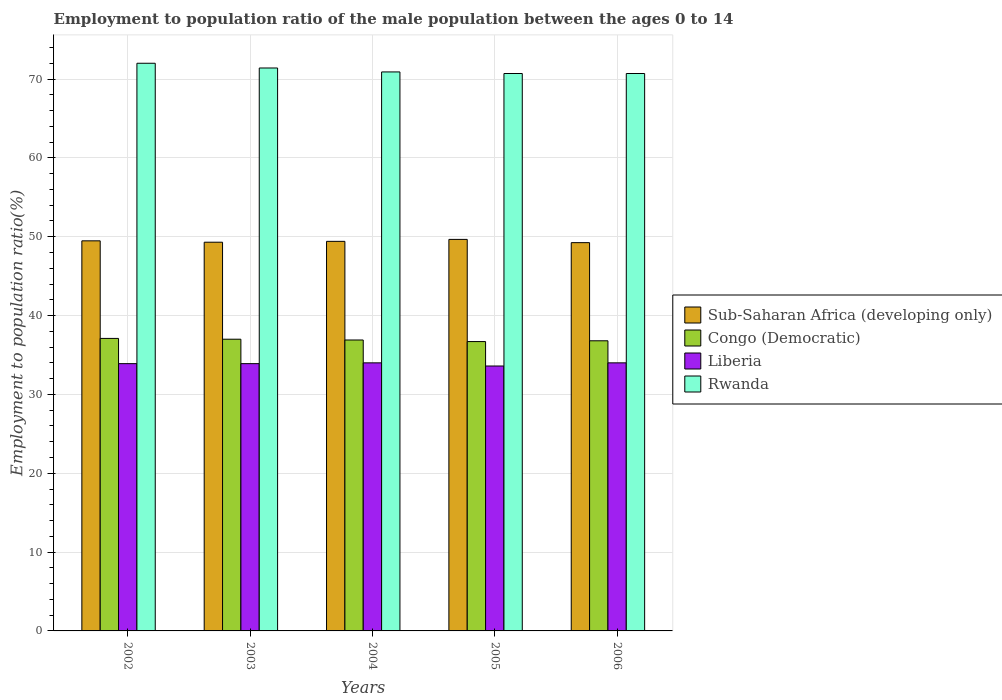How many different coloured bars are there?
Your answer should be very brief. 4. How many groups of bars are there?
Ensure brevity in your answer.  5. Are the number of bars per tick equal to the number of legend labels?
Give a very brief answer. Yes. Are the number of bars on each tick of the X-axis equal?
Keep it short and to the point. Yes. How many bars are there on the 4th tick from the left?
Provide a short and direct response. 4. What is the label of the 2nd group of bars from the left?
Provide a short and direct response. 2003. Across all years, what is the maximum employment to population ratio in Liberia?
Provide a succinct answer. 34. Across all years, what is the minimum employment to population ratio in Liberia?
Offer a terse response. 33.6. In which year was the employment to population ratio in Rwanda maximum?
Provide a succinct answer. 2002. In which year was the employment to population ratio in Rwanda minimum?
Provide a succinct answer. 2005. What is the total employment to population ratio in Rwanda in the graph?
Ensure brevity in your answer.  355.7. What is the difference between the employment to population ratio in Sub-Saharan Africa (developing only) in 2002 and that in 2004?
Provide a short and direct response. 0.07. What is the difference between the employment to population ratio in Congo (Democratic) in 2002 and the employment to population ratio in Sub-Saharan Africa (developing only) in 2004?
Offer a terse response. -12.31. What is the average employment to population ratio in Rwanda per year?
Provide a short and direct response. 71.14. In the year 2006, what is the difference between the employment to population ratio in Rwanda and employment to population ratio in Liberia?
Give a very brief answer. 36.7. What is the ratio of the employment to population ratio in Congo (Democratic) in 2002 to that in 2004?
Make the answer very short. 1.01. Is the difference between the employment to population ratio in Rwanda in 2002 and 2005 greater than the difference between the employment to population ratio in Liberia in 2002 and 2005?
Ensure brevity in your answer.  Yes. What is the difference between the highest and the second highest employment to population ratio in Rwanda?
Offer a terse response. 0.6. What is the difference between the highest and the lowest employment to population ratio in Liberia?
Give a very brief answer. 0.4. Is it the case that in every year, the sum of the employment to population ratio in Liberia and employment to population ratio in Congo (Democratic) is greater than the sum of employment to population ratio in Sub-Saharan Africa (developing only) and employment to population ratio in Rwanda?
Give a very brief answer. Yes. What does the 2nd bar from the left in 2004 represents?
Provide a succinct answer. Congo (Democratic). What does the 2nd bar from the right in 2006 represents?
Your answer should be very brief. Liberia. Is it the case that in every year, the sum of the employment to population ratio in Congo (Democratic) and employment to population ratio in Rwanda is greater than the employment to population ratio in Sub-Saharan Africa (developing only)?
Keep it short and to the point. Yes. How many bars are there?
Make the answer very short. 20. How many legend labels are there?
Provide a short and direct response. 4. How are the legend labels stacked?
Your answer should be compact. Vertical. What is the title of the graph?
Your answer should be very brief. Employment to population ratio of the male population between the ages 0 to 14. What is the label or title of the X-axis?
Ensure brevity in your answer.  Years. What is the Employment to population ratio(%) in Sub-Saharan Africa (developing only) in 2002?
Provide a short and direct response. 49.48. What is the Employment to population ratio(%) of Congo (Democratic) in 2002?
Your response must be concise. 37.1. What is the Employment to population ratio(%) of Liberia in 2002?
Your response must be concise. 33.9. What is the Employment to population ratio(%) in Sub-Saharan Africa (developing only) in 2003?
Provide a succinct answer. 49.3. What is the Employment to population ratio(%) of Liberia in 2003?
Keep it short and to the point. 33.9. What is the Employment to population ratio(%) of Rwanda in 2003?
Provide a short and direct response. 71.4. What is the Employment to population ratio(%) of Sub-Saharan Africa (developing only) in 2004?
Offer a very short reply. 49.41. What is the Employment to population ratio(%) of Congo (Democratic) in 2004?
Your answer should be compact. 36.9. What is the Employment to population ratio(%) of Liberia in 2004?
Keep it short and to the point. 34. What is the Employment to population ratio(%) in Rwanda in 2004?
Provide a succinct answer. 70.9. What is the Employment to population ratio(%) in Sub-Saharan Africa (developing only) in 2005?
Make the answer very short. 49.66. What is the Employment to population ratio(%) in Congo (Democratic) in 2005?
Your answer should be very brief. 36.7. What is the Employment to population ratio(%) of Liberia in 2005?
Offer a terse response. 33.6. What is the Employment to population ratio(%) of Rwanda in 2005?
Provide a succinct answer. 70.7. What is the Employment to population ratio(%) in Sub-Saharan Africa (developing only) in 2006?
Offer a very short reply. 49.25. What is the Employment to population ratio(%) in Congo (Democratic) in 2006?
Make the answer very short. 36.8. What is the Employment to population ratio(%) in Rwanda in 2006?
Your answer should be compact. 70.7. Across all years, what is the maximum Employment to population ratio(%) in Sub-Saharan Africa (developing only)?
Give a very brief answer. 49.66. Across all years, what is the maximum Employment to population ratio(%) of Congo (Democratic)?
Your answer should be very brief. 37.1. Across all years, what is the minimum Employment to population ratio(%) of Sub-Saharan Africa (developing only)?
Your response must be concise. 49.25. Across all years, what is the minimum Employment to population ratio(%) of Congo (Democratic)?
Ensure brevity in your answer.  36.7. Across all years, what is the minimum Employment to population ratio(%) of Liberia?
Keep it short and to the point. 33.6. Across all years, what is the minimum Employment to population ratio(%) in Rwanda?
Make the answer very short. 70.7. What is the total Employment to population ratio(%) of Sub-Saharan Africa (developing only) in the graph?
Give a very brief answer. 247.1. What is the total Employment to population ratio(%) of Congo (Democratic) in the graph?
Offer a terse response. 184.5. What is the total Employment to population ratio(%) of Liberia in the graph?
Make the answer very short. 169.4. What is the total Employment to population ratio(%) in Rwanda in the graph?
Provide a succinct answer. 355.7. What is the difference between the Employment to population ratio(%) in Sub-Saharan Africa (developing only) in 2002 and that in 2003?
Your answer should be compact. 0.18. What is the difference between the Employment to population ratio(%) of Sub-Saharan Africa (developing only) in 2002 and that in 2004?
Provide a short and direct response. 0.07. What is the difference between the Employment to population ratio(%) in Rwanda in 2002 and that in 2004?
Offer a very short reply. 1.1. What is the difference between the Employment to population ratio(%) of Sub-Saharan Africa (developing only) in 2002 and that in 2005?
Your answer should be compact. -0.18. What is the difference between the Employment to population ratio(%) of Congo (Democratic) in 2002 and that in 2005?
Ensure brevity in your answer.  0.4. What is the difference between the Employment to population ratio(%) in Sub-Saharan Africa (developing only) in 2002 and that in 2006?
Give a very brief answer. 0.23. What is the difference between the Employment to population ratio(%) of Congo (Democratic) in 2002 and that in 2006?
Keep it short and to the point. 0.3. What is the difference between the Employment to population ratio(%) in Rwanda in 2002 and that in 2006?
Offer a terse response. 1.3. What is the difference between the Employment to population ratio(%) in Sub-Saharan Africa (developing only) in 2003 and that in 2004?
Ensure brevity in your answer.  -0.11. What is the difference between the Employment to population ratio(%) of Rwanda in 2003 and that in 2004?
Keep it short and to the point. 0.5. What is the difference between the Employment to population ratio(%) of Sub-Saharan Africa (developing only) in 2003 and that in 2005?
Keep it short and to the point. -0.36. What is the difference between the Employment to population ratio(%) of Congo (Democratic) in 2003 and that in 2005?
Ensure brevity in your answer.  0.3. What is the difference between the Employment to population ratio(%) in Liberia in 2003 and that in 2005?
Keep it short and to the point. 0.3. What is the difference between the Employment to population ratio(%) in Sub-Saharan Africa (developing only) in 2003 and that in 2006?
Your answer should be very brief. 0.05. What is the difference between the Employment to population ratio(%) in Congo (Democratic) in 2003 and that in 2006?
Keep it short and to the point. 0.2. What is the difference between the Employment to population ratio(%) in Liberia in 2003 and that in 2006?
Your answer should be compact. -0.1. What is the difference between the Employment to population ratio(%) of Rwanda in 2003 and that in 2006?
Offer a terse response. 0.7. What is the difference between the Employment to population ratio(%) of Sub-Saharan Africa (developing only) in 2004 and that in 2005?
Provide a succinct answer. -0.25. What is the difference between the Employment to population ratio(%) of Congo (Democratic) in 2004 and that in 2005?
Your response must be concise. 0.2. What is the difference between the Employment to population ratio(%) of Liberia in 2004 and that in 2005?
Provide a succinct answer. 0.4. What is the difference between the Employment to population ratio(%) in Rwanda in 2004 and that in 2005?
Keep it short and to the point. 0.2. What is the difference between the Employment to population ratio(%) in Sub-Saharan Africa (developing only) in 2004 and that in 2006?
Offer a very short reply. 0.16. What is the difference between the Employment to population ratio(%) of Liberia in 2004 and that in 2006?
Provide a short and direct response. 0. What is the difference between the Employment to population ratio(%) of Rwanda in 2004 and that in 2006?
Offer a very short reply. 0.2. What is the difference between the Employment to population ratio(%) of Sub-Saharan Africa (developing only) in 2005 and that in 2006?
Your answer should be very brief. 0.41. What is the difference between the Employment to population ratio(%) in Congo (Democratic) in 2005 and that in 2006?
Keep it short and to the point. -0.1. What is the difference between the Employment to population ratio(%) in Liberia in 2005 and that in 2006?
Give a very brief answer. -0.4. What is the difference between the Employment to population ratio(%) of Rwanda in 2005 and that in 2006?
Your answer should be compact. 0. What is the difference between the Employment to population ratio(%) of Sub-Saharan Africa (developing only) in 2002 and the Employment to population ratio(%) of Congo (Democratic) in 2003?
Provide a succinct answer. 12.48. What is the difference between the Employment to population ratio(%) in Sub-Saharan Africa (developing only) in 2002 and the Employment to population ratio(%) in Liberia in 2003?
Make the answer very short. 15.58. What is the difference between the Employment to population ratio(%) of Sub-Saharan Africa (developing only) in 2002 and the Employment to population ratio(%) of Rwanda in 2003?
Provide a short and direct response. -21.92. What is the difference between the Employment to population ratio(%) of Congo (Democratic) in 2002 and the Employment to population ratio(%) of Rwanda in 2003?
Make the answer very short. -34.3. What is the difference between the Employment to population ratio(%) in Liberia in 2002 and the Employment to population ratio(%) in Rwanda in 2003?
Offer a very short reply. -37.5. What is the difference between the Employment to population ratio(%) of Sub-Saharan Africa (developing only) in 2002 and the Employment to population ratio(%) of Congo (Democratic) in 2004?
Offer a very short reply. 12.58. What is the difference between the Employment to population ratio(%) of Sub-Saharan Africa (developing only) in 2002 and the Employment to population ratio(%) of Liberia in 2004?
Offer a very short reply. 15.48. What is the difference between the Employment to population ratio(%) of Sub-Saharan Africa (developing only) in 2002 and the Employment to population ratio(%) of Rwanda in 2004?
Your answer should be compact. -21.42. What is the difference between the Employment to population ratio(%) of Congo (Democratic) in 2002 and the Employment to population ratio(%) of Rwanda in 2004?
Your answer should be very brief. -33.8. What is the difference between the Employment to population ratio(%) of Liberia in 2002 and the Employment to population ratio(%) of Rwanda in 2004?
Ensure brevity in your answer.  -37. What is the difference between the Employment to population ratio(%) in Sub-Saharan Africa (developing only) in 2002 and the Employment to population ratio(%) in Congo (Democratic) in 2005?
Provide a succinct answer. 12.78. What is the difference between the Employment to population ratio(%) in Sub-Saharan Africa (developing only) in 2002 and the Employment to population ratio(%) in Liberia in 2005?
Keep it short and to the point. 15.88. What is the difference between the Employment to population ratio(%) in Sub-Saharan Africa (developing only) in 2002 and the Employment to population ratio(%) in Rwanda in 2005?
Ensure brevity in your answer.  -21.22. What is the difference between the Employment to population ratio(%) of Congo (Democratic) in 2002 and the Employment to population ratio(%) of Liberia in 2005?
Your answer should be very brief. 3.5. What is the difference between the Employment to population ratio(%) of Congo (Democratic) in 2002 and the Employment to population ratio(%) of Rwanda in 2005?
Ensure brevity in your answer.  -33.6. What is the difference between the Employment to population ratio(%) in Liberia in 2002 and the Employment to population ratio(%) in Rwanda in 2005?
Your response must be concise. -36.8. What is the difference between the Employment to population ratio(%) in Sub-Saharan Africa (developing only) in 2002 and the Employment to population ratio(%) in Congo (Democratic) in 2006?
Ensure brevity in your answer.  12.68. What is the difference between the Employment to population ratio(%) of Sub-Saharan Africa (developing only) in 2002 and the Employment to population ratio(%) of Liberia in 2006?
Your answer should be very brief. 15.48. What is the difference between the Employment to population ratio(%) of Sub-Saharan Africa (developing only) in 2002 and the Employment to population ratio(%) of Rwanda in 2006?
Keep it short and to the point. -21.22. What is the difference between the Employment to population ratio(%) of Congo (Democratic) in 2002 and the Employment to population ratio(%) of Liberia in 2006?
Ensure brevity in your answer.  3.1. What is the difference between the Employment to population ratio(%) of Congo (Democratic) in 2002 and the Employment to population ratio(%) of Rwanda in 2006?
Keep it short and to the point. -33.6. What is the difference between the Employment to population ratio(%) in Liberia in 2002 and the Employment to population ratio(%) in Rwanda in 2006?
Your response must be concise. -36.8. What is the difference between the Employment to population ratio(%) in Sub-Saharan Africa (developing only) in 2003 and the Employment to population ratio(%) in Congo (Democratic) in 2004?
Keep it short and to the point. 12.4. What is the difference between the Employment to population ratio(%) of Sub-Saharan Africa (developing only) in 2003 and the Employment to population ratio(%) of Liberia in 2004?
Give a very brief answer. 15.3. What is the difference between the Employment to population ratio(%) of Sub-Saharan Africa (developing only) in 2003 and the Employment to population ratio(%) of Rwanda in 2004?
Your response must be concise. -21.6. What is the difference between the Employment to population ratio(%) of Congo (Democratic) in 2003 and the Employment to population ratio(%) of Liberia in 2004?
Your answer should be very brief. 3. What is the difference between the Employment to population ratio(%) in Congo (Democratic) in 2003 and the Employment to population ratio(%) in Rwanda in 2004?
Offer a terse response. -33.9. What is the difference between the Employment to population ratio(%) in Liberia in 2003 and the Employment to population ratio(%) in Rwanda in 2004?
Your answer should be compact. -37. What is the difference between the Employment to population ratio(%) in Sub-Saharan Africa (developing only) in 2003 and the Employment to population ratio(%) in Congo (Democratic) in 2005?
Provide a short and direct response. 12.6. What is the difference between the Employment to population ratio(%) in Sub-Saharan Africa (developing only) in 2003 and the Employment to population ratio(%) in Liberia in 2005?
Provide a short and direct response. 15.7. What is the difference between the Employment to population ratio(%) in Sub-Saharan Africa (developing only) in 2003 and the Employment to population ratio(%) in Rwanda in 2005?
Provide a short and direct response. -21.4. What is the difference between the Employment to population ratio(%) of Congo (Democratic) in 2003 and the Employment to population ratio(%) of Rwanda in 2005?
Offer a terse response. -33.7. What is the difference between the Employment to population ratio(%) in Liberia in 2003 and the Employment to population ratio(%) in Rwanda in 2005?
Offer a very short reply. -36.8. What is the difference between the Employment to population ratio(%) of Sub-Saharan Africa (developing only) in 2003 and the Employment to population ratio(%) of Congo (Democratic) in 2006?
Give a very brief answer. 12.5. What is the difference between the Employment to population ratio(%) in Sub-Saharan Africa (developing only) in 2003 and the Employment to population ratio(%) in Liberia in 2006?
Give a very brief answer. 15.3. What is the difference between the Employment to population ratio(%) of Sub-Saharan Africa (developing only) in 2003 and the Employment to population ratio(%) of Rwanda in 2006?
Give a very brief answer. -21.4. What is the difference between the Employment to population ratio(%) in Congo (Democratic) in 2003 and the Employment to population ratio(%) in Rwanda in 2006?
Offer a very short reply. -33.7. What is the difference between the Employment to population ratio(%) of Liberia in 2003 and the Employment to population ratio(%) of Rwanda in 2006?
Ensure brevity in your answer.  -36.8. What is the difference between the Employment to population ratio(%) of Sub-Saharan Africa (developing only) in 2004 and the Employment to population ratio(%) of Congo (Democratic) in 2005?
Your answer should be very brief. 12.71. What is the difference between the Employment to population ratio(%) in Sub-Saharan Africa (developing only) in 2004 and the Employment to population ratio(%) in Liberia in 2005?
Give a very brief answer. 15.81. What is the difference between the Employment to population ratio(%) in Sub-Saharan Africa (developing only) in 2004 and the Employment to population ratio(%) in Rwanda in 2005?
Your response must be concise. -21.29. What is the difference between the Employment to population ratio(%) of Congo (Democratic) in 2004 and the Employment to population ratio(%) of Rwanda in 2005?
Provide a succinct answer. -33.8. What is the difference between the Employment to population ratio(%) in Liberia in 2004 and the Employment to population ratio(%) in Rwanda in 2005?
Make the answer very short. -36.7. What is the difference between the Employment to population ratio(%) in Sub-Saharan Africa (developing only) in 2004 and the Employment to population ratio(%) in Congo (Democratic) in 2006?
Your answer should be compact. 12.61. What is the difference between the Employment to population ratio(%) of Sub-Saharan Africa (developing only) in 2004 and the Employment to population ratio(%) of Liberia in 2006?
Your answer should be compact. 15.41. What is the difference between the Employment to population ratio(%) of Sub-Saharan Africa (developing only) in 2004 and the Employment to population ratio(%) of Rwanda in 2006?
Offer a terse response. -21.29. What is the difference between the Employment to population ratio(%) of Congo (Democratic) in 2004 and the Employment to population ratio(%) of Rwanda in 2006?
Offer a very short reply. -33.8. What is the difference between the Employment to population ratio(%) of Liberia in 2004 and the Employment to population ratio(%) of Rwanda in 2006?
Ensure brevity in your answer.  -36.7. What is the difference between the Employment to population ratio(%) in Sub-Saharan Africa (developing only) in 2005 and the Employment to population ratio(%) in Congo (Democratic) in 2006?
Your answer should be very brief. 12.86. What is the difference between the Employment to population ratio(%) of Sub-Saharan Africa (developing only) in 2005 and the Employment to population ratio(%) of Liberia in 2006?
Make the answer very short. 15.66. What is the difference between the Employment to population ratio(%) of Sub-Saharan Africa (developing only) in 2005 and the Employment to population ratio(%) of Rwanda in 2006?
Your answer should be compact. -21.04. What is the difference between the Employment to population ratio(%) of Congo (Democratic) in 2005 and the Employment to population ratio(%) of Rwanda in 2006?
Keep it short and to the point. -34. What is the difference between the Employment to population ratio(%) in Liberia in 2005 and the Employment to population ratio(%) in Rwanda in 2006?
Offer a very short reply. -37.1. What is the average Employment to population ratio(%) of Sub-Saharan Africa (developing only) per year?
Give a very brief answer. 49.42. What is the average Employment to population ratio(%) of Congo (Democratic) per year?
Offer a terse response. 36.9. What is the average Employment to population ratio(%) in Liberia per year?
Offer a very short reply. 33.88. What is the average Employment to population ratio(%) in Rwanda per year?
Give a very brief answer. 71.14. In the year 2002, what is the difference between the Employment to population ratio(%) in Sub-Saharan Africa (developing only) and Employment to population ratio(%) in Congo (Democratic)?
Provide a short and direct response. 12.38. In the year 2002, what is the difference between the Employment to population ratio(%) of Sub-Saharan Africa (developing only) and Employment to population ratio(%) of Liberia?
Your answer should be very brief. 15.58. In the year 2002, what is the difference between the Employment to population ratio(%) of Sub-Saharan Africa (developing only) and Employment to population ratio(%) of Rwanda?
Your response must be concise. -22.52. In the year 2002, what is the difference between the Employment to population ratio(%) in Congo (Democratic) and Employment to population ratio(%) in Rwanda?
Offer a very short reply. -34.9. In the year 2002, what is the difference between the Employment to population ratio(%) of Liberia and Employment to population ratio(%) of Rwanda?
Provide a succinct answer. -38.1. In the year 2003, what is the difference between the Employment to population ratio(%) of Sub-Saharan Africa (developing only) and Employment to population ratio(%) of Congo (Democratic)?
Make the answer very short. 12.3. In the year 2003, what is the difference between the Employment to population ratio(%) of Sub-Saharan Africa (developing only) and Employment to population ratio(%) of Liberia?
Your response must be concise. 15.4. In the year 2003, what is the difference between the Employment to population ratio(%) in Sub-Saharan Africa (developing only) and Employment to population ratio(%) in Rwanda?
Offer a very short reply. -22.1. In the year 2003, what is the difference between the Employment to population ratio(%) of Congo (Democratic) and Employment to population ratio(%) of Rwanda?
Offer a terse response. -34.4. In the year 2003, what is the difference between the Employment to population ratio(%) of Liberia and Employment to population ratio(%) of Rwanda?
Your answer should be very brief. -37.5. In the year 2004, what is the difference between the Employment to population ratio(%) in Sub-Saharan Africa (developing only) and Employment to population ratio(%) in Congo (Democratic)?
Your answer should be very brief. 12.51. In the year 2004, what is the difference between the Employment to population ratio(%) in Sub-Saharan Africa (developing only) and Employment to population ratio(%) in Liberia?
Your answer should be compact. 15.41. In the year 2004, what is the difference between the Employment to population ratio(%) in Sub-Saharan Africa (developing only) and Employment to population ratio(%) in Rwanda?
Your response must be concise. -21.49. In the year 2004, what is the difference between the Employment to population ratio(%) of Congo (Democratic) and Employment to population ratio(%) of Rwanda?
Your response must be concise. -34. In the year 2004, what is the difference between the Employment to population ratio(%) of Liberia and Employment to population ratio(%) of Rwanda?
Your answer should be very brief. -36.9. In the year 2005, what is the difference between the Employment to population ratio(%) of Sub-Saharan Africa (developing only) and Employment to population ratio(%) of Congo (Democratic)?
Make the answer very short. 12.96. In the year 2005, what is the difference between the Employment to population ratio(%) of Sub-Saharan Africa (developing only) and Employment to population ratio(%) of Liberia?
Offer a very short reply. 16.06. In the year 2005, what is the difference between the Employment to population ratio(%) of Sub-Saharan Africa (developing only) and Employment to population ratio(%) of Rwanda?
Offer a very short reply. -21.04. In the year 2005, what is the difference between the Employment to population ratio(%) in Congo (Democratic) and Employment to population ratio(%) in Rwanda?
Give a very brief answer. -34. In the year 2005, what is the difference between the Employment to population ratio(%) in Liberia and Employment to population ratio(%) in Rwanda?
Your answer should be very brief. -37.1. In the year 2006, what is the difference between the Employment to population ratio(%) of Sub-Saharan Africa (developing only) and Employment to population ratio(%) of Congo (Democratic)?
Offer a terse response. 12.45. In the year 2006, what is the difference between the Employment to population ratio(%) of Sub-Saharan Africa (developing only) and Employment to population ratio(%) of Liberia?
Provide a succinct answer. 15.25. In the year 2006, what is the difference between the Employment to population ratio(%) of Sub-Saharan Africa (developing only) and Employment to population ratio(%) of Rwanda?
Your answer should be very brief. -21.45. In the year 2006, what is the difference between the Employment to population ratio(%) in Congo (Democratic) and Employment to population ratio(%) in Rwanda?
Offer a very short reply. -33.9. In the year 2006, what is the difference between the Employment to population ratio(%) in Liberia and Employment to population ratio(%) in Rwanda?
Your response must be concise. -36.7. What is the ratio of the Employment to population ratio(%) in Sub-Saharan Africa (developing only) in 2002 to that in 2003?
Offer a very short reply. 1. What is the ratio of the Employment to population ratio(%) of Rwanda in 2002 to that in 2003?
Offer a terse response. 1.01. What is the ratio of the Employment to population ratio(%) of Sub-Saharan Africa (developing only) in 2002 to that in 2004?
Make the answer very short. 1. What is the ratio of the Employment to population ratio(%) of Congo (Democratic) in 2002 to that in 2004?
Keep it short and to the point. 1.01. What is the ratio of the Employment to population ratio(%) of Liberia in 2002 to that in 2004?
Your answer should be compact. 1. What is the ratio of the Employment to population ratio(%) of Rwanda in 2002 to that in 2004?
Ensure brevity in your answer.  1.02. What is the ratio of the Employment to population ratio(%) in Sub-Saharan Africa (developing only) in 2002 to that in 2005?
Keep it short and to the point. 1. What is the ratio of the Employment to population ratio(%) in Congo (Democratic) in 2002 to that in 2005?
Provide a succinct answer. 1.01. What is the ratio of the Employment to population ratio(%) in Liberia in 2002 to that in 2005?
Your response must be concise. 1.01. What is the ratio of the Employment to population ratio(%) in Rwanda in 2002 to that in 2005?
Your answer should be very brief. 1.02. What is the ratio of the Employment to population ratio(%) in Congo (Democratic) in 2002 to that in 2006?
Your answer should be very brief. 1.01. What is the ratio of the Employment to population ratio(%) of Liberia in 2002 to that in 2006?
Provide a succinct answer. 1. What is the ratio of the Employment to population ratio(%) of Rwanda in 2002 to that in 2006?
Offer a terse response. 1.02. What is the ratio of the Employment to population ratio(%) of Sub-Saharan Africa (developing only) in 2003 to that in 2004?
Provide a short and direct response. 1. What is the ratio of the Employment to population ratio(%) in Rwanda in 2003 to that in 2004?
Give a very brief answer. 1.01. What is the ratio of the Employment to population ratio(%) of Sub-Saharan Africa (developing only) in 2003 to that in 2005?
Your answer should be very brief. 0.99. What is the ratio of the Employment to population ratio(%) in Congo (Democratic) in 2003 to that in 2005?
Your answer should be very brief. 1.01. What is the ratio of the Employment to population ratio(%) of Liberia in 2003 to that in 2005?
Keep it short and to the point. 1.01. What is the ratio of the Employment to population ratio(%) of Rwanda in 2003 to that in 2005?
Offer a terse response. 1.01. What is the ratio of the Employment to population ratio(%) in Sub-Saharan Africa (developing only) in 2003 to that in 2006?
Your answer should be very brief. 1. What is the ratio of the Employment to population ratio(%) of Congo (Democratic) in 2003 to that in 2006?
Your answer should be compact. 1.01. What is the ratio of the Employment to population ratio(%) of Rwanda in 2003 to that in 2006?
Make the answer very short. 1.01. What is the ratio of the Employment to population ratio(%) in Sub-Saharan Africa (developing only) in 2004 to that in 2005?
Give a very brief answer. 0.99. What is the ratio of the Employment to population ratio(%) in Congo (Democratic) in 2004 to that in 2005?
Provide a succinct answer. 1.01. What is the ratio of the Employment to population ratio(%) of Liberia in 2004 to that in 2005?
Offer a terse response. 1.01. What is the ratio of the Employment to population ratio(%) in Rwanda in 2004 to that in 2005?
Give a very brief answer. 1. What is the ratio of the Employment to population ratio(%) of Congo (Democratic) in 2004 to that in 2006?
Your answer should be compact. 1. What is the ratio of the Employment to population ratio(%) of Rwanda in 2004 to that in 2006?
Ensure brevity in your answer.  1. What is the ratio of the Employment to population ratio(%) of Sub-Saharan Africa (developing only) in 2005 to that in 2006?
Provide a succinct answer. 1.01. What is the ratio of the Employment to population ratio(%) in Congo (Democratic) in 2005 to that in 2006?
Your response must be concise. 1. What is the ratio of the Employment to population ratio(%) of Liberia in 2005 to that in 2006?
Offer a terse response. 0.99. What is the difference between the highest and the second highest Employment to population ratio(%) of Sub-Saharan Africa (developing only)?
Provide a succinct answer. 0.18. What is the difference between the highest and the second highest Employment to population ratio(%) of Congo (Democratic)?
Your response must be concise. 0.1. What is the difference between the highest and the second highest Employment to population ratio(%) in Rwanda?
Provide a short and direct response. 0.6. What is the difference between the highest and the lowest Employment to population ratio(%) of Sub-Saharan Africa (developing only)?
Give a very brief answer. 0.41. What is the difference between the highest and the lowest Employment to population ratio(%) of Congo (Democratic)?
Provide a succinct answer. 0.4. 